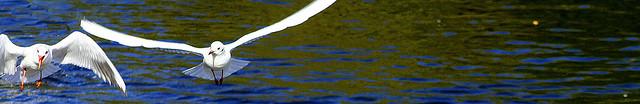What is the main color of the picture?
Short answer required. Blue. What kind of animal is this?
Concise answer only. Seagull. What color are the birds?
Be succinct. White. Are the birds touching each other?
Be succinct. No. What type of birds are these?
Quick response, please. Seagulls. 